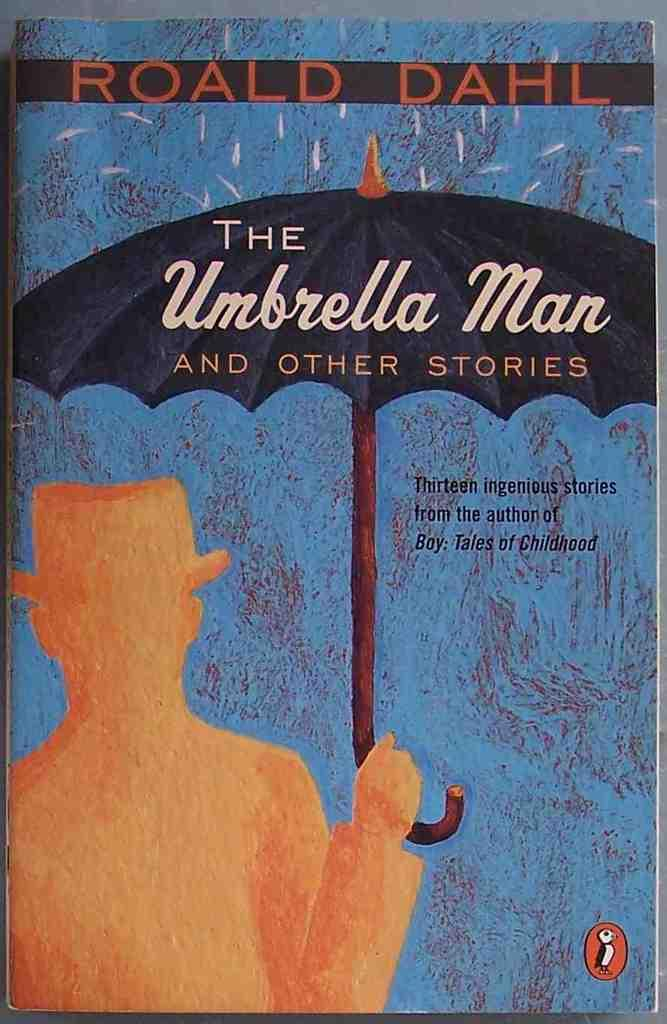Provide a one-sentence caption for the provided image. A book of stories by Roald Dahl titled "The Umbrella Man and Other Stories". 